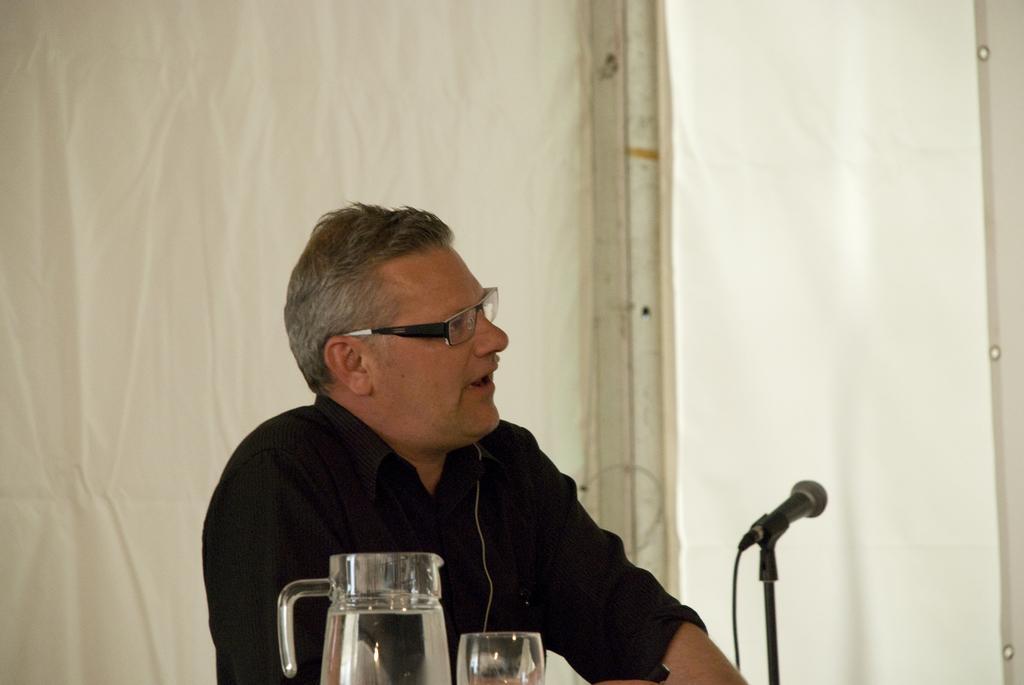Please provide a concise description of this image. In this image there is a person wearing a shirt and spectacles. Bottom of the image there is a mike stand, glass and a jar. Background there is a curtain. 